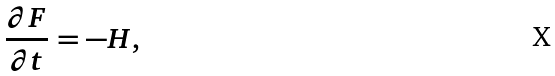Convert formula to latex. <formula><loc_0><loc_0><loc_500><loc_500>\frac { \partial F } { \partial t } = - H ,</formula> 